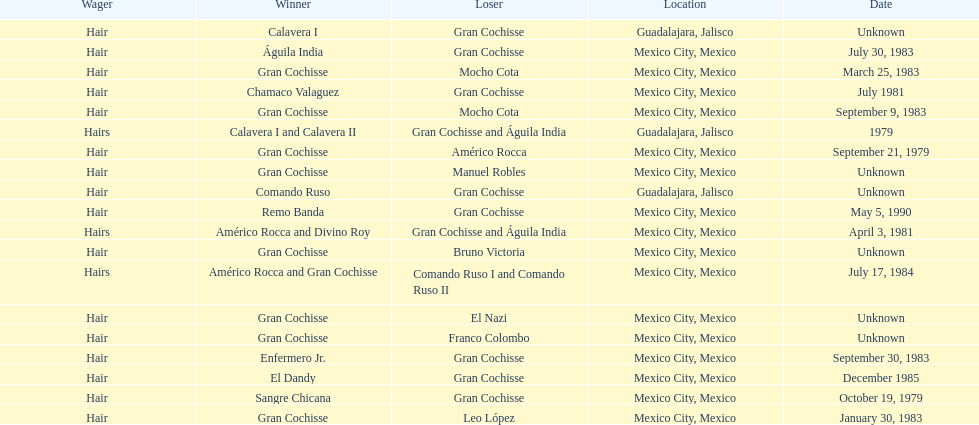When did bruno victoria lose his first game? Unknown. 